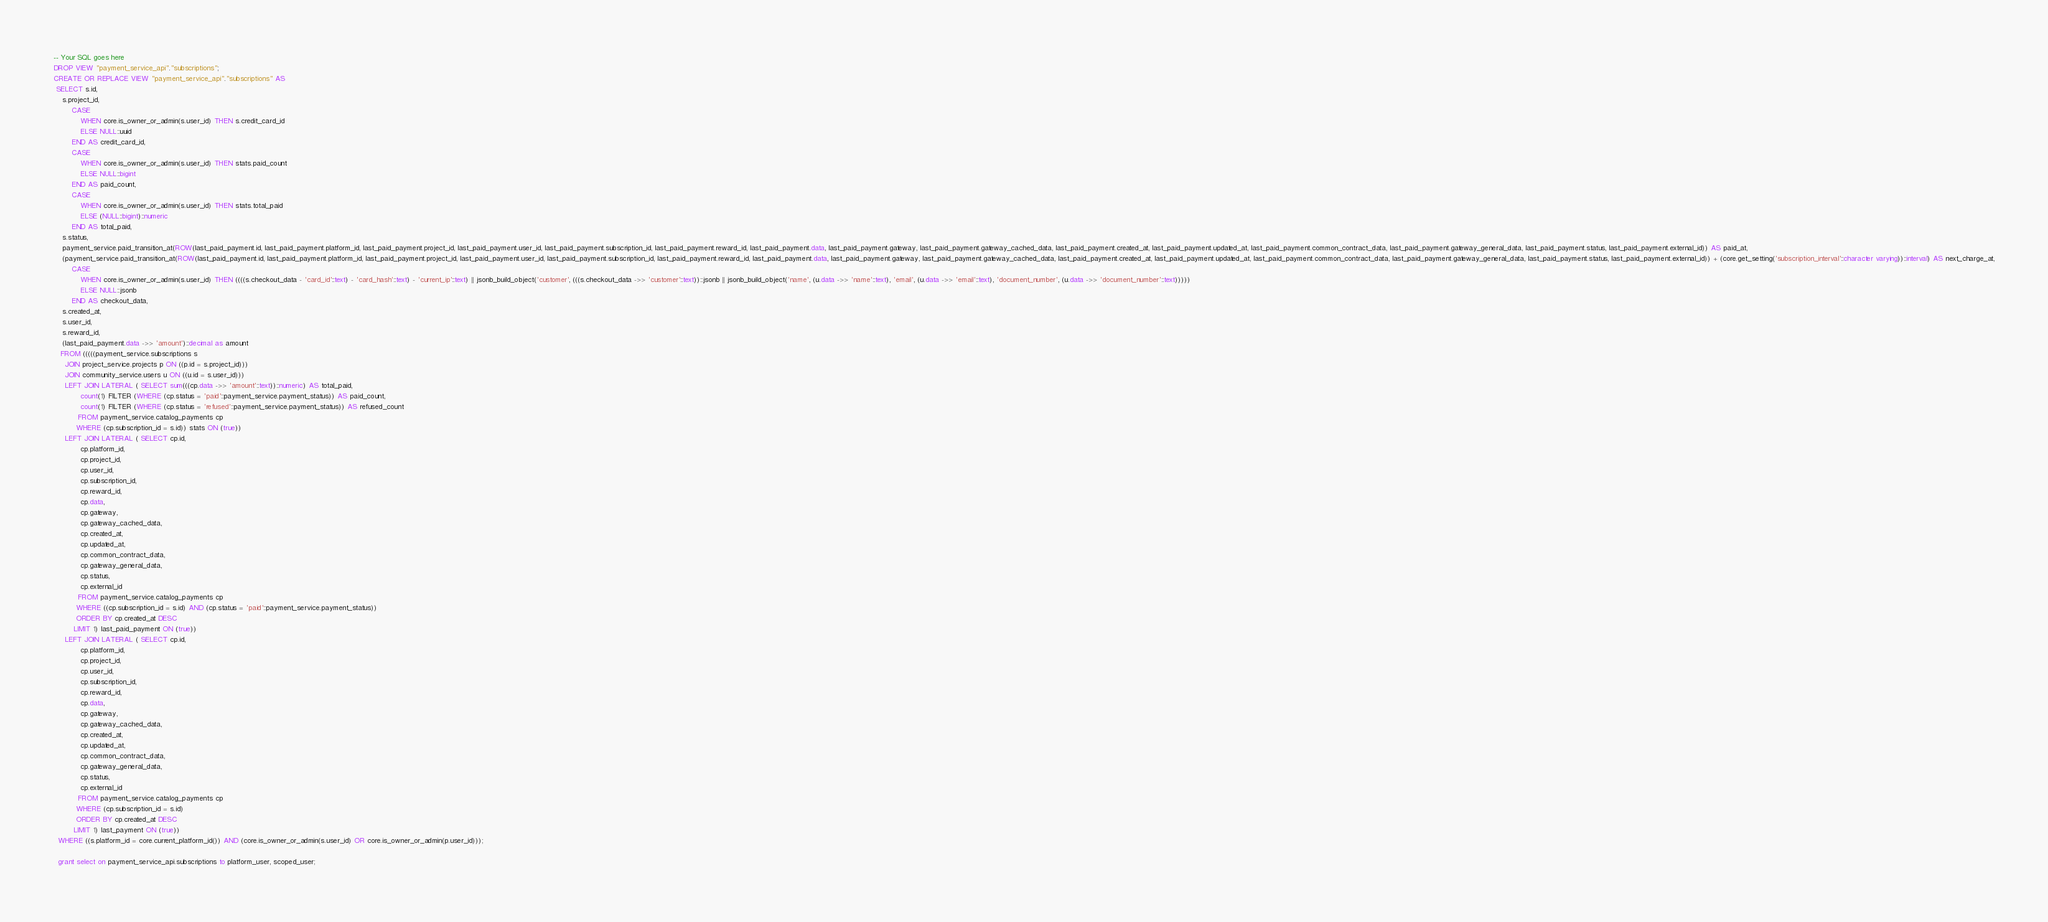Convert code to text. <code><loc_0><loc_0><loc_500><loc_500><_SQL_>-- Your SQL goes here
DROP VIEW "payment_service_api"."subscriptions";
CREATE OR REPLACE VIEW "payment_service_api"."subscriptions" AS 
 SELECT s.id,
    s.project_id,
        CASE
            WHEN core.is_owner_or_admin(s.user_id) THEN s.credit_card_id
            ELSE NULL::uuid
        END AS credit_card_id,
        CASE
            WHEN core.is_owner_or_admin(s.user_id) THEN stats.paid_count
            ELSE NULL::bigint
        END AS paid_count,
        CASE
            WHEN core.is_owner_or_admin(s.user_id) THEN stats.total_paid
            ELSE (NULL::bigint)::numeric
        END AS total_paid,
    s.status,
    payment_service.paid_transition_at(ROW(last_paid_payment.id, last_paid_payment.platform_id, last_paid_payment.project_id, last_paid_payment.user_id, last_paid_payment.subscription_id, last_paid_payment.reward_id, last_paid_payment.data, last_paid_payment.gateway, last_paid_payment.gateway_cached_data, last_paid_payment.created_at, last_paid_payment.updated_at, last_paid_payment.common_contract_data, last_paid_payment.gateway_general_data, last_paid_payment.status, last_paid_payment.external_id)) AS paid_at,
    (payment_service.paid_transition_at(ROW(last_paid_payment.id, last_paid_payment.platform_id, last_paid_payment.project_id, last_paid_payment.user_id, last_paid_payment.subscription_id, last_paid_payment.reward_id, last_paid_payment.data, last_paid_payment.gateway, last_paid_payment.gateway_cached_data, last_paid_payment.created_at, last_paid_payment.updated_at, last_paid_payment.common_contract_data, last_paid_payment.gateway_general_data, last_paid_payment.status, last_paid_payment.external_id)) + (core.get_setting('subscription_interval'::character varying))::interval) AS next_charge_at,
        CASE
            WHEN core.is_owner_or_admin(s.user_id) THEN ((((s.checkout_data - 'card_id'::text) - 'card_hash'::text) - 'current_ip'::text) || jsonb_build_object('customer', (((s.checkout_data ->> 'customer'::text))::jsonb || jsonb_build_object('name', (u.data ->> 'name'::text), 'email', (u.data ->> 'email'::text), 'document_number', (u.data ->> 'document_number'::text)))))
            ELSE NULL::jsonb
        END AS checkout_data,
    s.created_at,
    s.user_id,
    s.reward_id,
    (last_paid_payment.data ->> 'amount')::decimal as amount
   FROM (((((payment_service.subscriptions s
     JOIN project_service.projects p ON ((p.id = s.project_id)))
     JOIN community_service.users u ON ((u.id = s.user_id)))
     LEFT JOIN LATERAL ( SELECT sum(((cp.data ->> 'amount'::text))::numeric) AS total_paid,
            count(1) FILTER (WHERE (cp.status = 'paid'::payment_service.payment_status)) AS paid_count,
            count(1) FILTER (WHERE (cp.status = 'refused'::payment_service.payment_status)) AS refused_count
           FROM payment_service.catalog_payments cp
          WHERE (cp.subscription_id = s.id)) stats ON (true))
     LEFT JOIN LATERAL ( SELECT cp.id,
            cp.platform_id,
            cp.project_id,
            cp.user_id,
            cp.subscription_id,
            cp.reward_id,
            cp.data,
            cp.gateway,
            cp.gateway_cached_data,
            cp.created_at,
            cp.updated_at,
            cp.common_contract_data,
            cp.gateway_general_data,
            cp.status,
            cp.external_id
           FROM payment_service.catalog_payments cp
          WHERE ((cp.subscription_id = s.id) AND (cp.status = 'paid'::payment_service.payment_status))
          ORDER BY cp.created_at DESC
         LIMIT 1) last_paid_payment ON (true))
     LEFT JOIN LATERAL ( SELECT cp.id,
            cp.platform_id,
            cp.project_id,
            cp.user_id,
            cp.subscription_id,
            cp.reward_id,
            cp.data,
            cp.gateway,
            cp.gateway_cached_data,
            cp.created_at,
            cp.updated_at,
            cp.common_contract_data,
            cp.gateway_general_data,
            cp.status,
            cp.external_id
           FROM payment_service.catalog_payments cp
          WHERE (cp.subscription_id = s.id)
          ORDER BY cp.created_at DESC
         LIMIT 1) last_payment ON (true))
  WHERE ((s.platform_id = core.current_platform_id()) AND (core.is_owner_or_admin(s.user_id) OR core.is_owner_or_admin(p.user_id)));
  
  grant select on payment_service_api.subscriptions to platform_user, scoped_user;</code> 